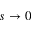Convert formula to latex. <formula><loc_0><loc_0><loc_500><loc_500>s \rightarrow 0</formula> 